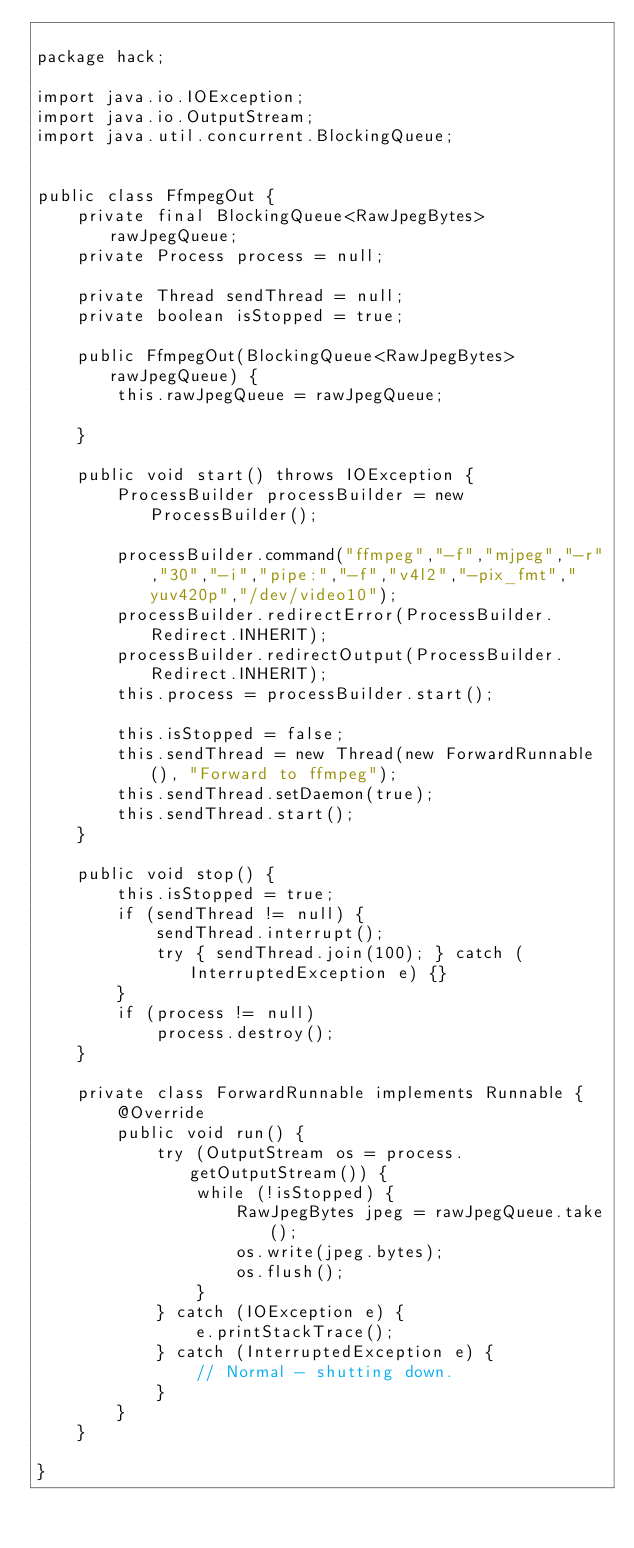<code> <loc_0><loc_0><loc_500><loc_500><_Java_>
package hack;

import java.io.IOException;
import java.io.OutputStream;
import java.util.concurrent.BlockingQueue;


public class FfmpegOut {
    private final BlockingQueue<RawJpegBytes> rawJpegQueue;
    private Process process = null;
    
    private Thread sendThread = null;
    private boolean isStopped = true;
    
    public FfmpegOut(BlockingQueue<RawJpegBytes> rawJpegQueue) {
        this.rawJpegQueue = rawJpegQueue;
        
    }
    
    public void start() throws IOException {
        ProcessBuilder processBuilder = new ProcessBuilder();
        
        processBuilder.command("ffmpeg","-f","mjpeg","-r","30","-i","pipe:","-f","v4l2","-pix_fmt","yuv420p","/dev/video10");
        processBuilder.redirectError(ProcessBuilder.Redirect.INHERIT);
        processBuilder.redirectOutput(ProcessBuilder.Redirect.INHERIT);
        this.process = processBuilder.start();
        
        this.isStopped = false;
        this.sendThread = new Thread(new ForwardRunnable(), "Forward to ffmpeg");
        this.sendThread.setDaemon(true);
        this.sendThread.start();
    }
    
    public void stop() {
        this.isStopped = true;
        if (sendThread != null) {
            sendThread.interrupt();
            try { sendThread.join(100); } catch (InterruptedException e) {}
        }
        if (process != null)
            process.destroy();
    }
    
    private class ForwardRunnable implements Runnable {
        @Override
        public void run() {
            try (OutputStream os = process.getOutputStream()) {
                while (!isStopped) {
                    RawJpegBytes jpeg = rawJpegQueue.take();
                    os.write(jpeg.bytes);
                    os.flush();
                }
            } catch (IOException e) {
                e.printStackTrace();
            } catch (InterruptedException e) {
                // Normal - shutting down.
            }
        }
    }

}
</code> 